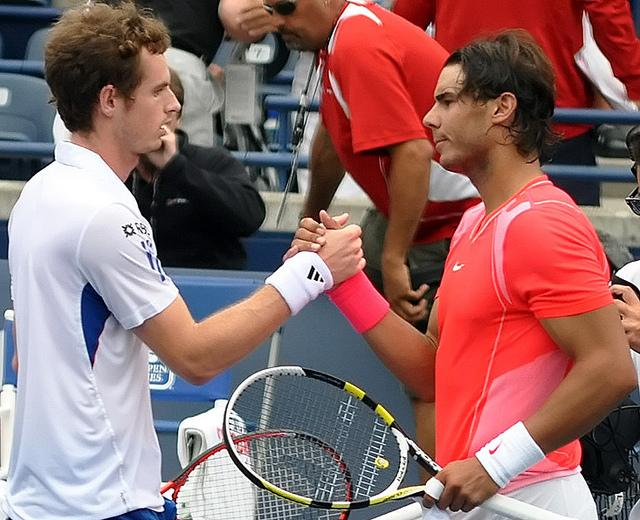What did the two men shaking hands just do?

Choices:
A) had lunch
B) played baseball
C) went bowling
D) played tennis played tennis 